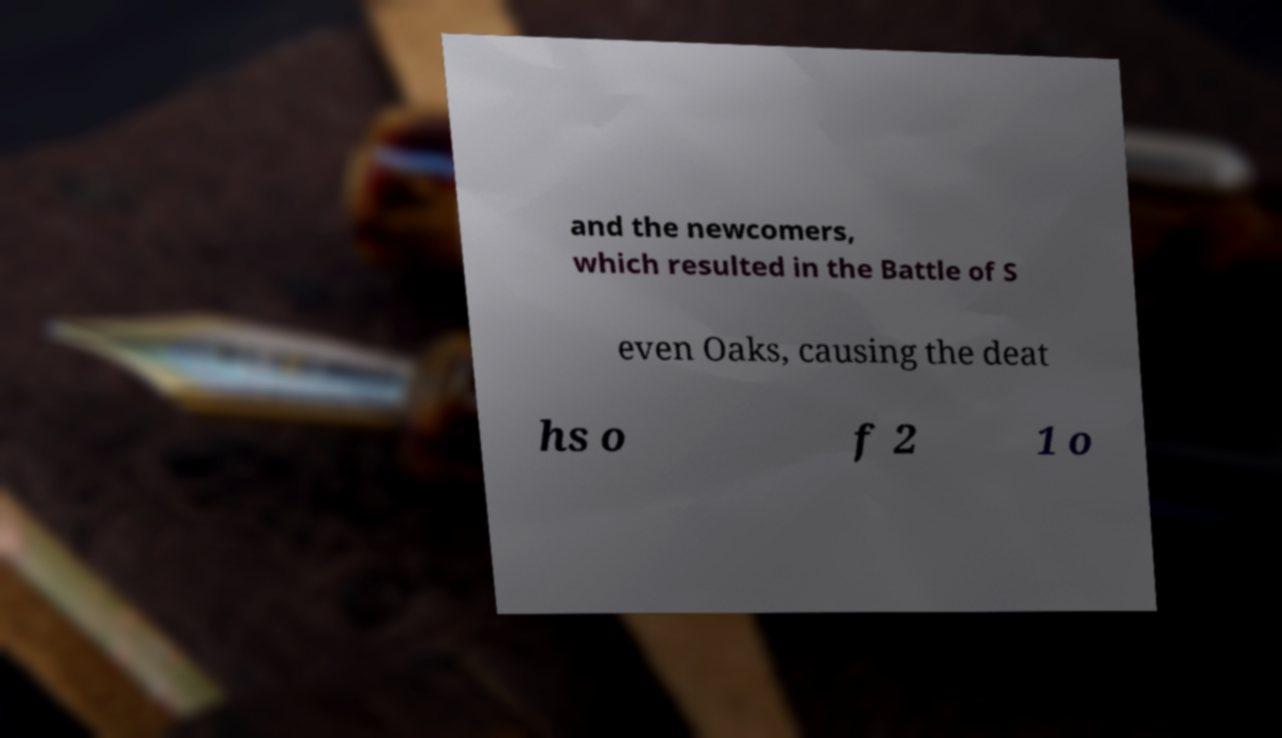Can you accurately transcribe the text from the provided image for me? and the newcomers, which resulted in the Battle of S even Oaks, causing the deat hs o f 2 1 o 